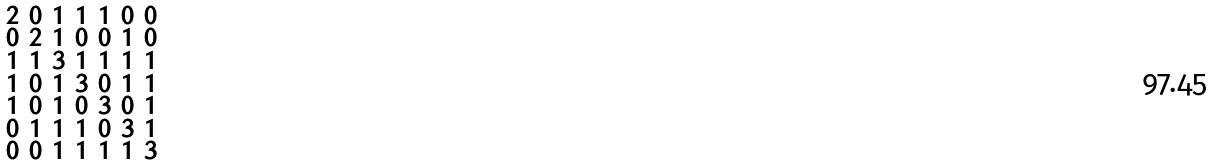Convert formula to latex. <formula><loc_0><loc_0><loc_500><loc_500>\begin{smallmatrix} 2 & 0 & 1 & 1 & 1 & 0 & 0 \\ 0 & 2 & 1 & 0 & 0 & 1 & 0 \\ 1 & 1 & 3 & 1 & 1 & 1 & 1 \\ 1 & 0 & 1 & 3 & 0 & 1 & 1 \\ 1 & 0 & 1 & 0 & 3 & 0 & 1 \\ 0 & 1 & 1 & 1 & 0 & 3 & 1 \\ 0 & 0 & 1 & 1 & 1 & 1 & 3 \end{smallmatrix}</formula> 